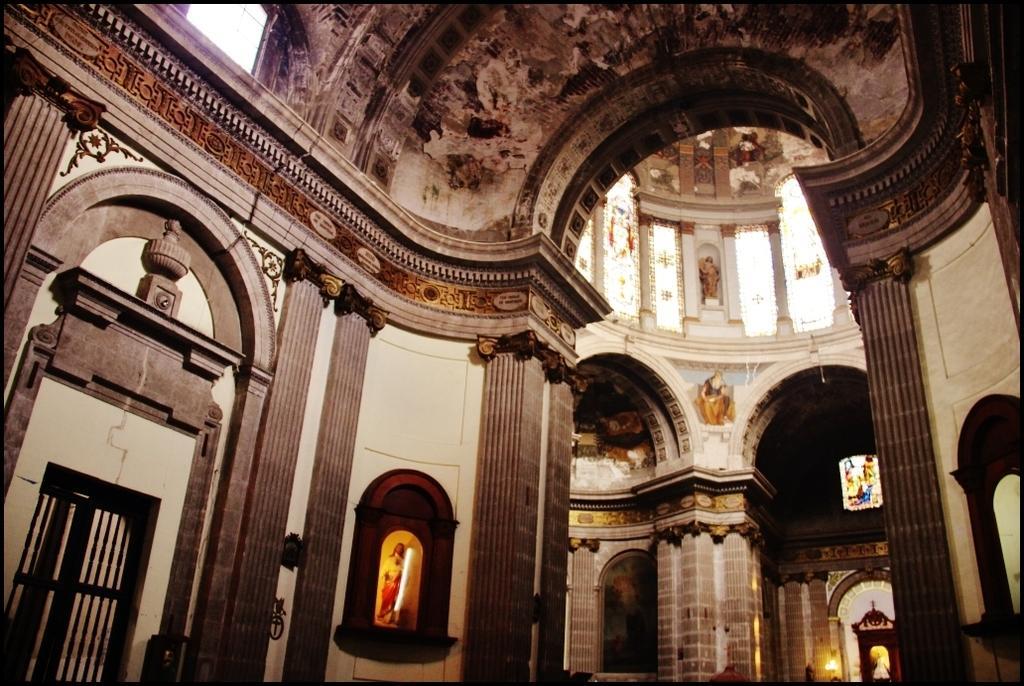Describe this image in one or two sentences. In this image we can see the inside view of a building, there are windows and statues in the shelf. 